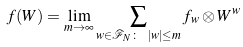<formula> <loc_0><loc_0><loc_500><loc_500>f ( W ) = \lim _ { m \rightarrow \infty } \sum _ { w \in \mathcal { F } _ { N } \colon \ | w | \leq m } f _ { w } \otimes W ^ { w }</formula> 